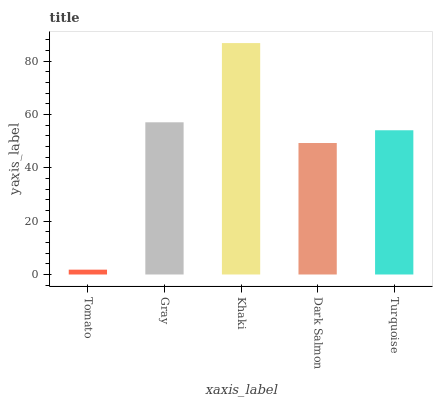Is Tomato the minimum?
Answer yes or no. Yes. Is Khaki the maximum?
Answer yes or no. Yes. Is Gray the minimum?
Answer yes or no. No. Is Gray the maximum?
Answer yes or no. No. Is Gray greater than Tomato?
Answer yes or no. Yes. Is Tomato less than Gray?
Answer yes or no. Yes. Is Tomato greater than Gray?
Answer yes or no. No. Is Gray less than Tomato?
Answer yes or no. No. Is Turquoise the high median?
Answer yes or no. Yes. Is Turquoise the low median?
Answer yes or no. Yes. Is Dark Salmon the high median?
Answer yes or no. No. Is Gray the low median?
Answer yes or no. No. 